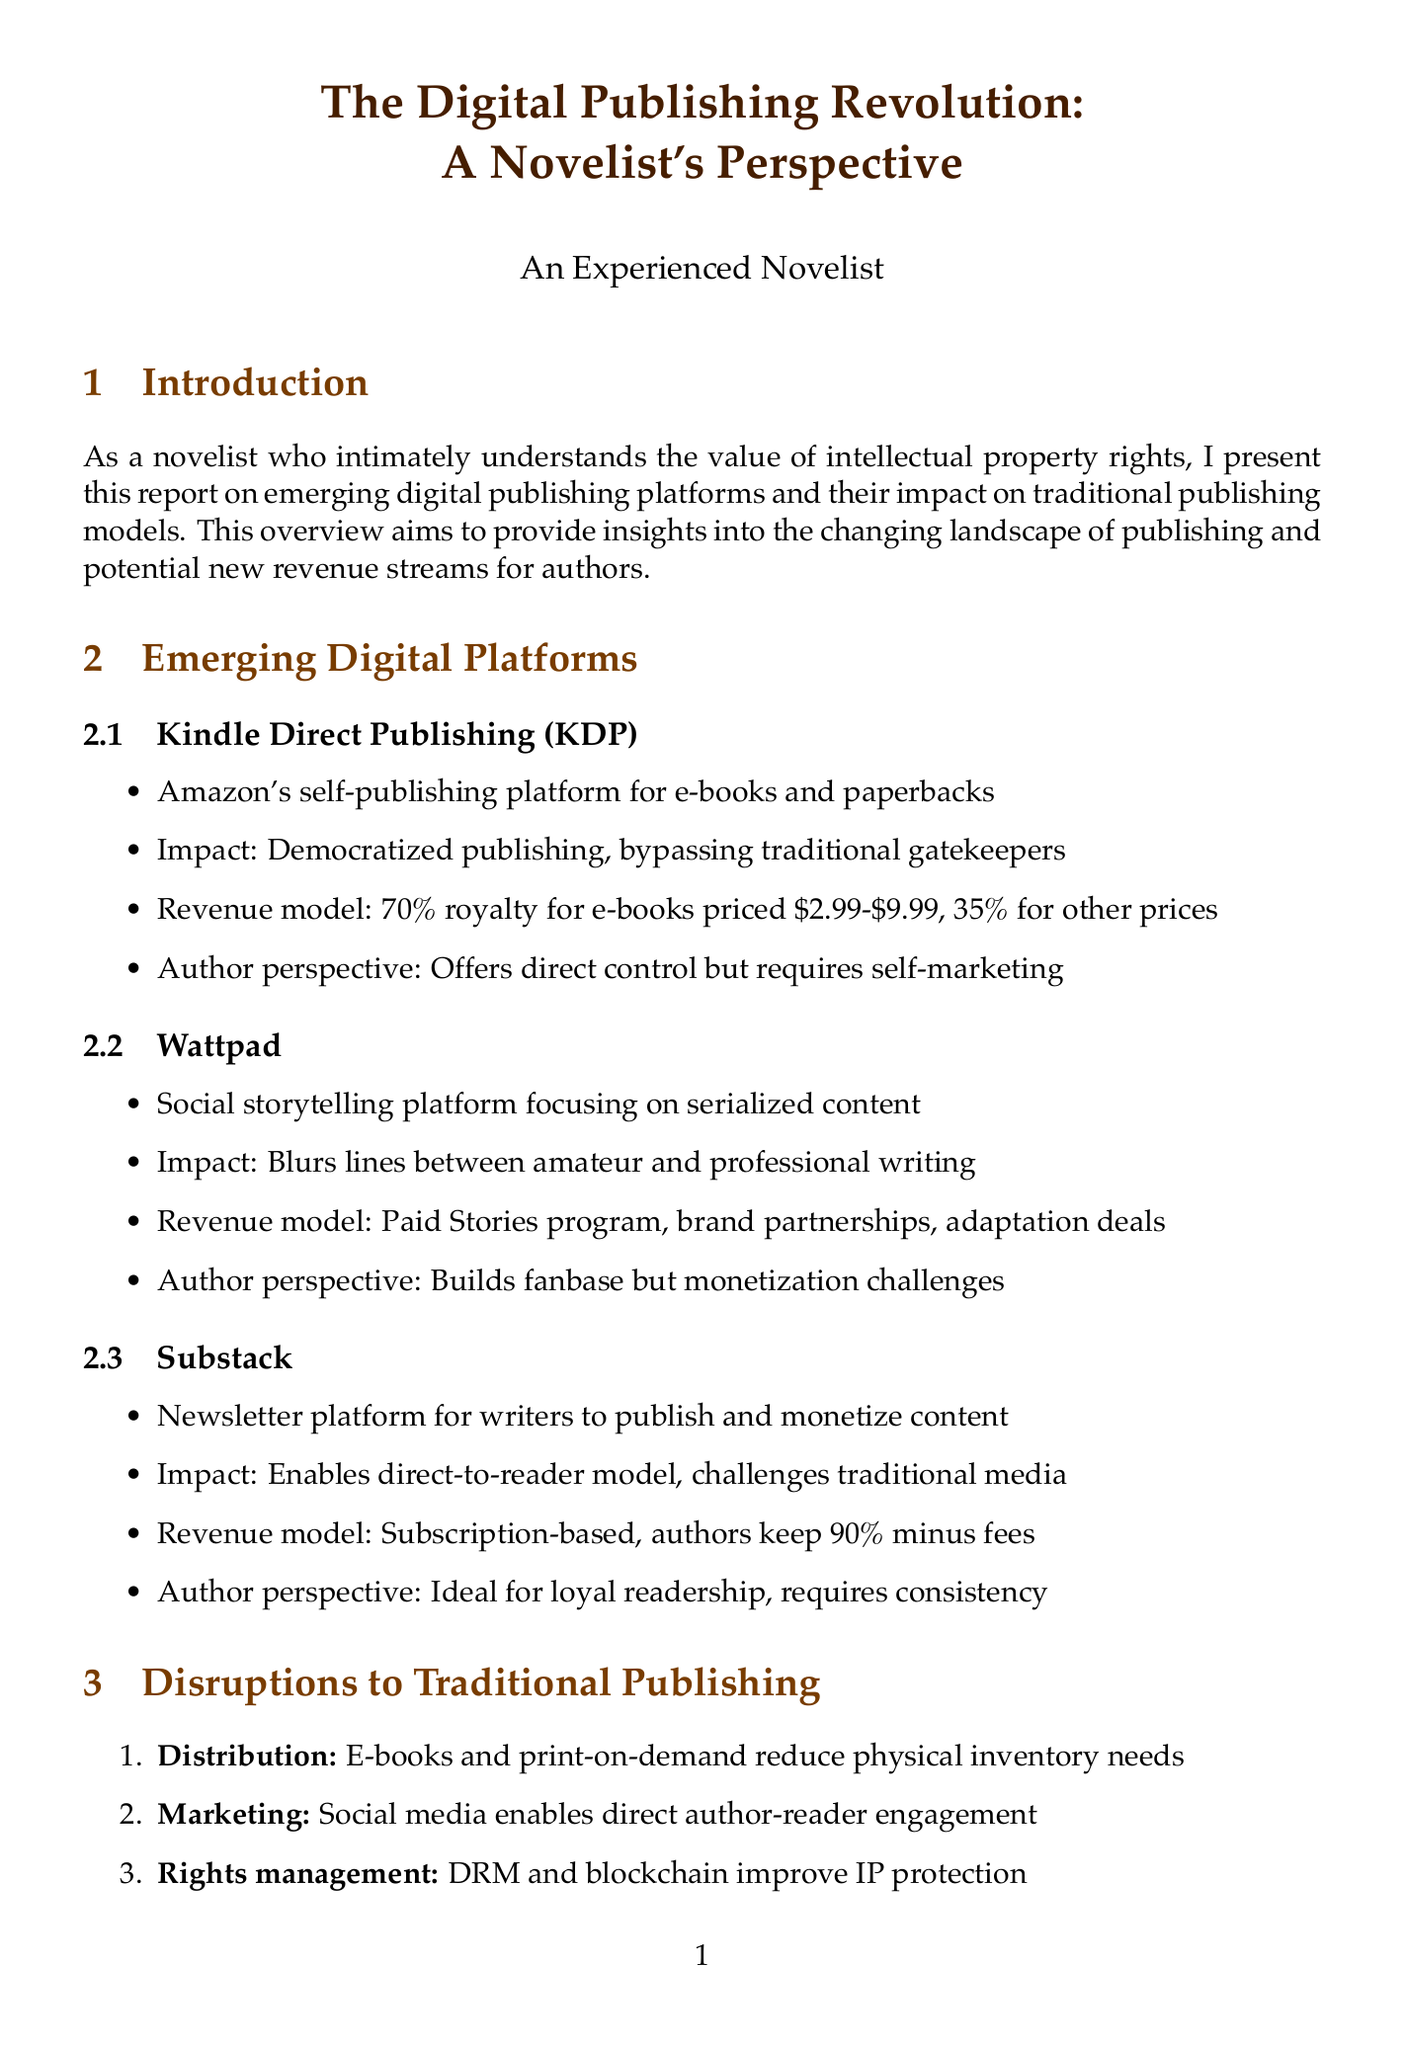What is the revenue model for Kindle Direct Publishing? The revenue model for KDP includes a 70% royalty for e-books priced $2.99-$9.99, and 35% for other prices.
Answer: 70% for $2.99-$9.99, 35% for other prices What platform allows crowdfunding for authors? The crowdfunding platform mentioned for authors is Kickstarter.
Answer: Kickstarter What is the main impact of Wattpad? Wattpad's main impact is that it blurs the lines between amateur and professional writing and fosters community engagement.
Answer: Blurs lines between amateur and professional writing How do social media changes affect author marketing? Social media enables direct author-reader engagement, which provides greater control over branding and requires increased responsibility for promotion.
Answer: Direct author-reader engagement What new revenue stream involves monetizing expertise? The new revenue stream involves virtual events and online courses through platforms like Teachable.
Answer: Virtual events and online courses What is a potential drawback of audio rights and production? A potential drawback of audio rights and production is the production costs.
Answer: Production costs Which author self-published "The Martian" before achieving bestseller status? The author who self-published "The Martian" is Andy Weir.
Answer: Andy Weir What technology is mentioned for better protection and tracking of intellectual property? The technology mentioned for IP protection is DRM and blockchain.
Answer: DRM and blockchain What is the potential impact of augmented reality books? The potential impact of augmented reality books is enhanced reading experiences and new storytelling possibilities.
Answer: Enhanced reading experiences 